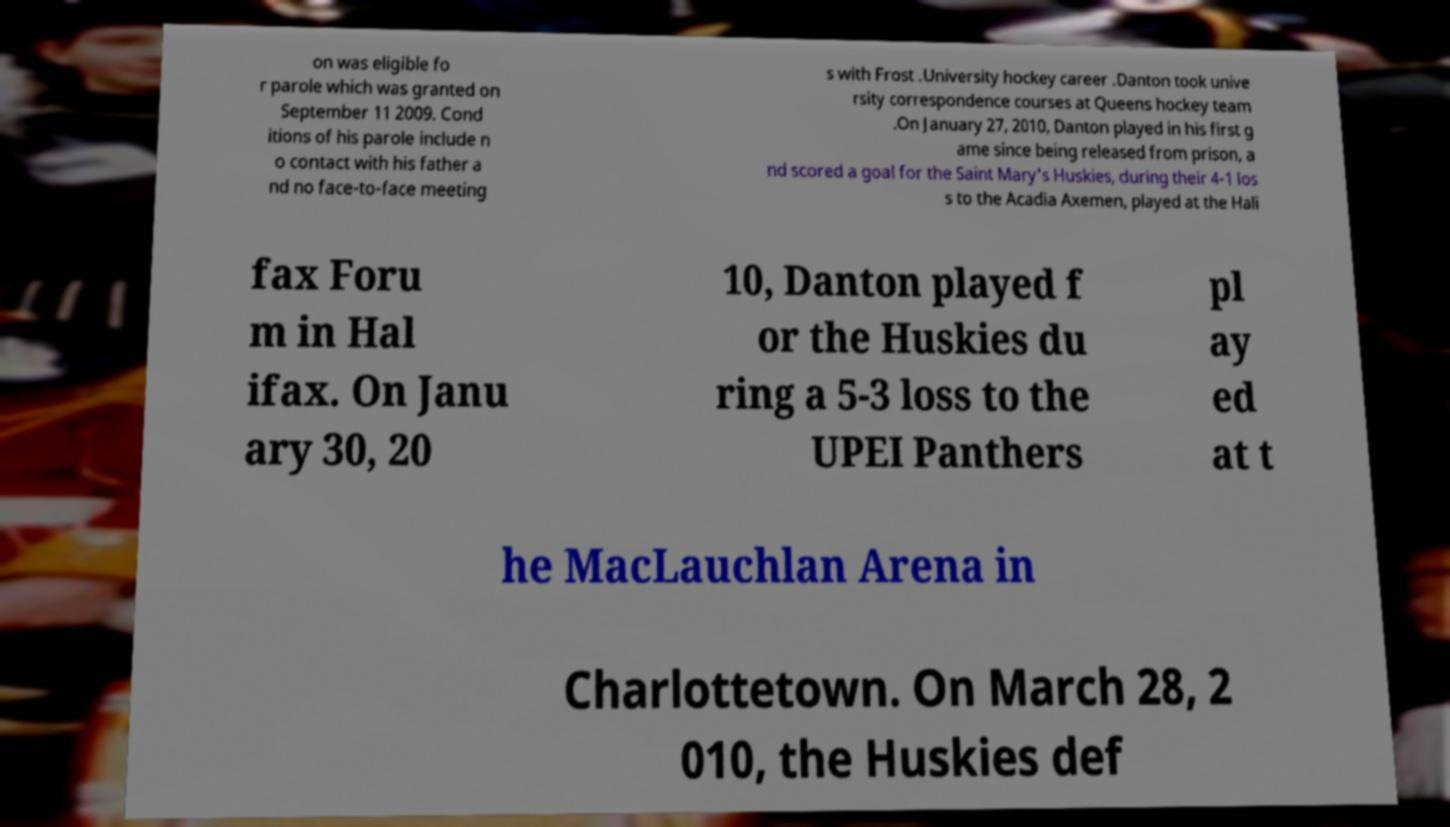Could you assist in decoding the text presented in this image and type it out clearly? on was eligible fo r parole which was granted on September 11 2009. Cond itions of his parole include n o contact with his father a nd no face-to-face meeting s with Frost .University hockey career .Danton took unive rsity correspondence courses at Queens hockey team .On January 27, 2010, Danton played in his first g ame since being released from prison, a nd scored a goal for the Saint Mary's Huskies, during their 4-1 los s to the Acadia Axemen, played at the Hali fax Foru m in Hal ifax. On Janu ary 30, 20 10, Danton played f or the Huskies du ring a 5-3 loss to the UPEI Panthers pl ay ed at t he MacLauchlan Arena in Charlottetown. On March 28, 2 010, the Huskies def 